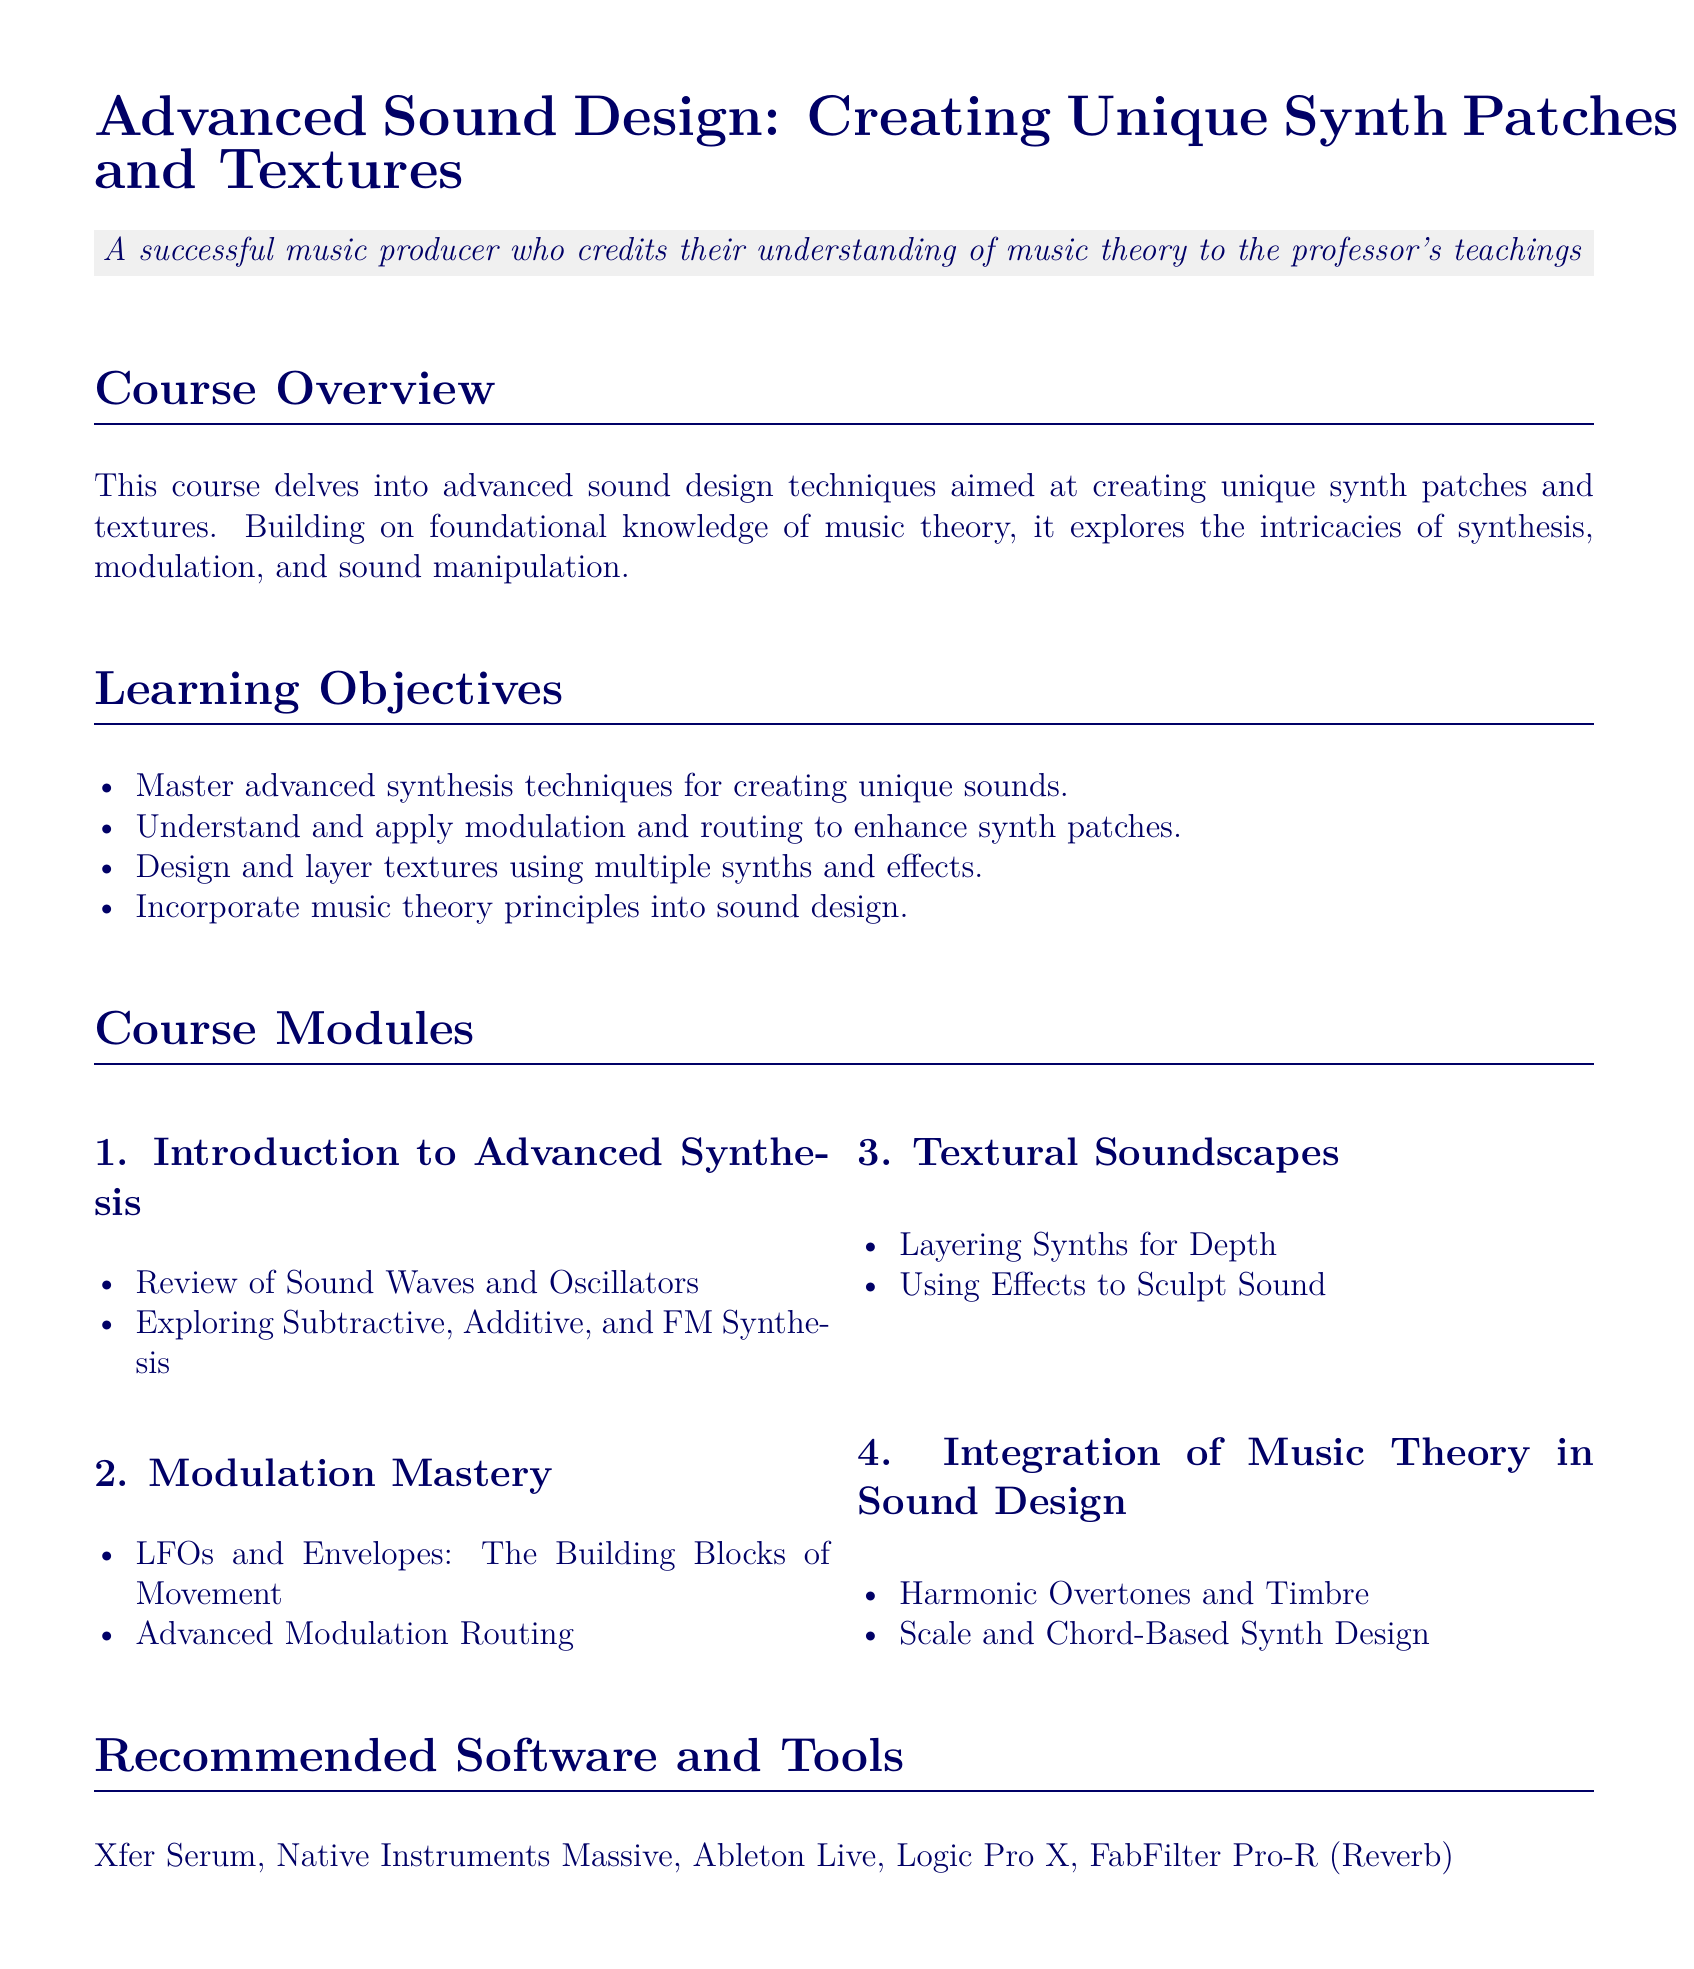What is the course title? The course title is listed at the top of the syllabus.
Answer: Advanced Sound Design: Creating Unique Synth Patches and Textures How many learning objectives are listed? The document mentions a list of learning objectives in the Learning Objectives section.
Answer: Four What software is recommended for the course? The recommended software is detailed in the Recommended Software and Tools section.
Answer: Xfer Serum, Native Instruments Massive, Ableton Live, Logic Pro X, FabFilter Pro-R What is the main focus of Module 2? Module 2 centers around a specific aspect of sound design, detailed in its title.
Answer: Modulation Mastery Who is the author of the recommended book "The Art of Synthesizer Programming"? The author is mentioned in the Further Readings and Resources section.
Answer: Howard Massey What type of assignment is the final project? The nature of the final project is described in the Assessment Methods section.
Answer: Designing a complete piece of music In which module do students learn about Scale and Chord-Based Synth Design? The modules are outlined, indicating the focus of each.
Answer: Module 4 What is one of the assessment methods? The assessment methods are clearly listed in a dedicated section.
Answer: Practical Assignments 